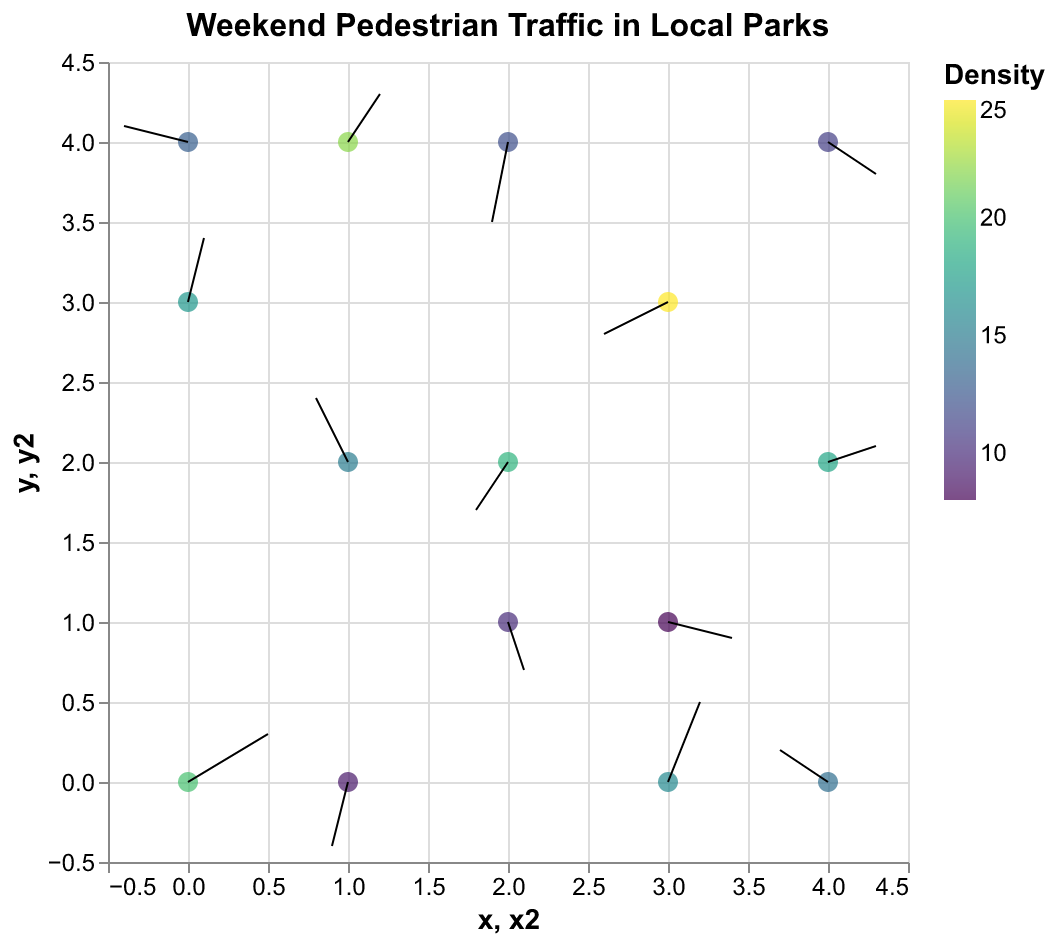What's the title of the figure? The title is displayed at the top of the figure. It reads "Weekend Pedestrian Traffic in Local Parks".
Answer: "Weekend Pedestrian Traffic in Local Parks" What feature does the color of the points represent? The color of the points indicates the density of pedestrian traffic. Darker colors generally represent higher densities based on the color gradient shown in the legend.
Answer: Density How are the directions and lengths of arrows determined in the plot? The direction and length of each arrow are determined by the u (horizontal component) and v (vertical component) values found at each (x, y) location. The transformation calculates the end position (x + u, y + v) to display the arrows.
Answer: By u and v components Which point has the highest pedestrian density, and what is its value? From the color and legend scale, the darkest point indicates the highest density. The point at coordinates (3, 3) has the highest value with a density of 25.
Answer: (3, 3), 25 What are the coordinates and density of the point with the arrow pointing diagonally down to the left? An arrow pointing diagonally down to the left would have both u and v negative. The point with coordinates (2, 2) fits this description, and its density is 19.
Answer: (2, 2), 19 What's the average pedestrian density across all points in the plot? Add all density values and divide by the number of points: (20 + 15 + 10 + 25 + 18 + 12 + 22 + 8 + 14 + 17 + 19 + 11 + 13 + 16 + 9) / 15 = 229 / 15 ≈ 15.27
Answer: 15.27 Compare the pedestrian density at (1, 2) and (4, 0). Which is higher and by how much? The density at (1, 2) is 15, and at (4, 0) it is 14. The density at (1, 2) is higher by 1 (15 - 14 = 1).
Answer: (1, 2) is higher by 1 Which direction does the arrow at (0, 0) point, and what does this indicate about pedestrian movement? The arrow at (0, 0) points to the right and slightly upward (positive u and v), indicating that pedestrians are moving in that general direction from this starting point.
Answer: Right and slightly upward Find the coordinates where pedestrians shift their direction most dramatically, based on arrows. The most dramatic directional shift can be found at (3, 3) with the highest density, showing the most noticeable vector with u = -0.4, v = -0.2, indicating movement down and to the left.
Answer: (3, 3) How many points are present in the plot? By counting the number of unique (x, y) coordinates listed, there are 15 points in the plot.
Answer: 15 